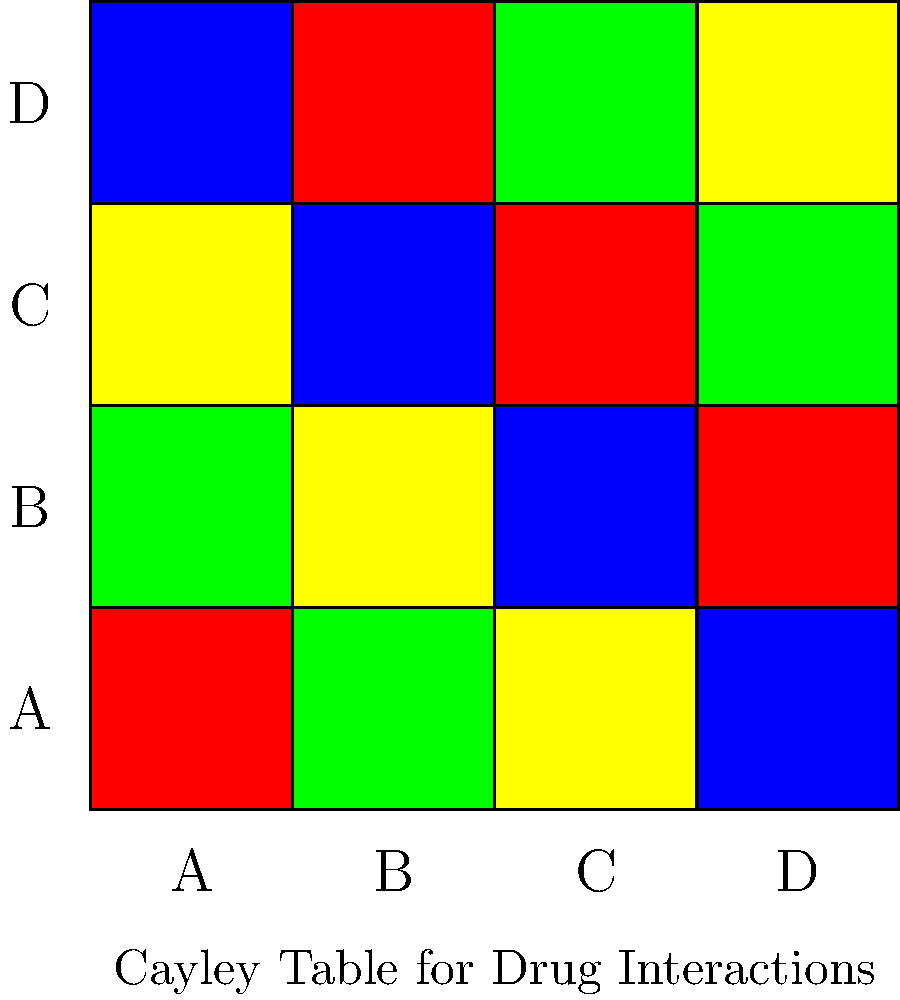In the Cayley table shown above, drug interactions are represented by colors. Red indicates a severe interaction, yellow a moderate interaction, green a mild interaction, and blue no interaction. If you are currently taking drug A and considering adding drug C, what level of interaction should you be concerned about? To determine the level of interaction between drug A and drug C using the Cayley table, we need to follow these steps:

1. Locate drug A on the horizontal axis (top row).
2. Find drug C on the vertical axis (leftmost column).
3. Identify the color at the intersection of the row (drug C) and column (drug A).

Looking at the table:
1. Drug A is the first column.
2. Drug C is the third row.
3. The intersection of drug A's column and drug C's row is colored yellow.

In the given color scheme:
- Red: severe interaction
- Yellow: moderate interaction
- Green: mild interaction
- Blue: no interaction

Therefore, the yellow color at the intersection indicates a moderate interaction between drug A and drug C.
Answer: Moderate interaction 